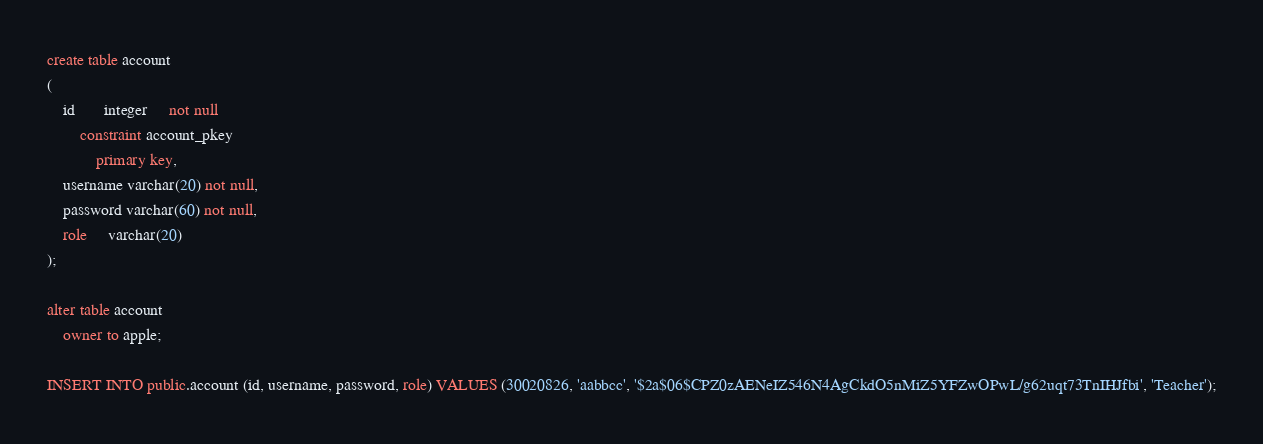Convert code to text. <code><loc_0><loc_0><loc_500><loc_500><_SQL_>create table account
(
    id       integer     not null
        constraint account_pkey
            primary key,
    username varchar(20) not null,
    password varchar(60) not null,
    role     varchar(20)
);

alter table account
    owner to apple;

INSERT INTO public.account (id, username, password, role) VALUES (30020826, 'aabbcc', '$2a$06$CPZ0zAENeIZ546N4AgCkdO5nMiZ5YFZwOPwL/g62uqt73TnIHJfbi', 'Teacher');</code> 